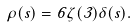Convert formula to latex. <formula><loc_0><loc_0><loc_500><loc_500>\rho ( s ) = 6 \zeta ( 3 ) \delta ( s ) .</formula> 